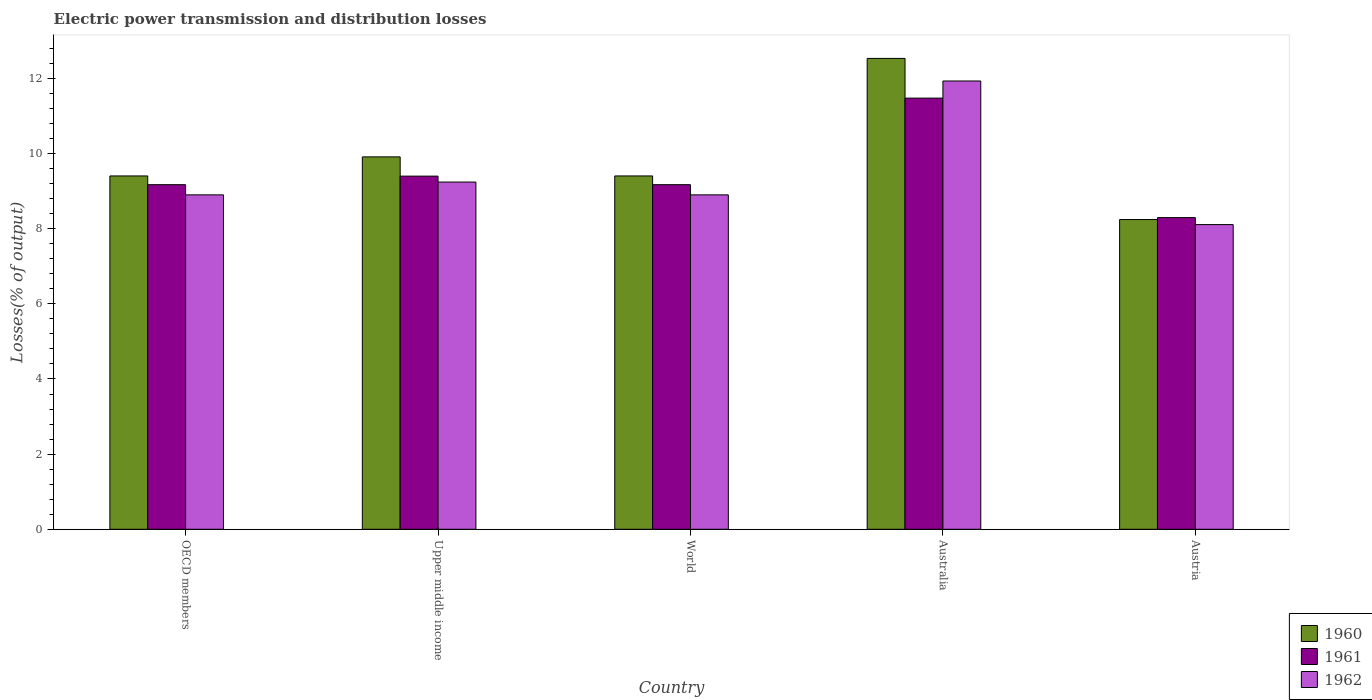How many different coloured bars are there?
Offer a terse response. 3. Are the number of bars per tick equal to the number of legend labels?
Offer a very short reply. Yes. Are the number of bars on each tick of the X-axis equal?
Offer a terse response. Yes. What is the electric power transmission and distribution losses in 1962 in World?
Offer a very short reply. 8.9. Across all countries, what is the maximum electric power transmission and distribution losses in 1962?
Give a very brief answer. 11.93. Across all countries, what is the minimum electric power transmission and distribution losses in 1962?
Provide a succinct answer. 8.11. What is the total electric power transmission and distribution losses in 1961 in the graph?
Provide a succinct answer. 47.51. What is the difference between the electric power transmission and distribution losses in 1962 in OECD members and that in Upper middle income?
Offer a very short reply. -0.34. What is the difference between the electric power transmission and distribution losses in 1962 in Upper middle income and the electric power transmission and distribution losses in 1961 in OECD members?
Give a very brief answer. 0.07. What is the average electric power transmission and distribution losses in 1961 per country?
Ensure brevity in your answer.  9.5. What is the difference between the electric power transmission and distribution losses of/in 1961 and electric power transmission and distribution losses of/in 1960 in OECD members?
Provide a short and direct response. -0.23. In how many countries, is the electric power transmission and distribution losses in 1962 greater than 4.4 %?
Offer a very short reply. 5. What is the ratio of the electric power transmission and distribution losses in 1961 in Austria to that in OECD members?
Keep it short and to the point. 0.9. Is the difference between the electric power transmission and distribution losses in 1961 in Austria and OECD members greater than the difference between the electric power transmission and distribution losses in 1960 in Austria and OECD members?
Provide a short and direct response. Yes. What is the difference between the highest and the second highest electric power transmission and distribution losses in 1962?
Offer a terse response. -0.34. What is the difference between the highest and the lowest electric power transmission and distribution losses in 1961?
Your response must be concise. 3.18. In how many countries, is the electric power transmission and distribution losses in 1962 greater than the average electric power transmission and distribution losses in 1962 taken over all countries?
Offer a terse response. 1. How many countries are there in the graph?
Provide a succinct answer. 5. What is the difference between two consecutive major ticks on the Y-axis?
Offer a terse response. 2. Are the values on the major ticks of Y-axis written in scientific E-notation?
Give a very brief answer. No. Does the graph contain any zero values?
Offer a very short reply. No. How many legend labels are there?
Your response must be concise. 3. What is the title of the graph?
Your answer should be compact. Electric power transmission and distribution losses. Does "1992" appear as one of the legend labels in the graph?
Provide a short and direct response. No. What is the label or title of the X-axis?
Make the answer very short. Country. What is the label or title of the Y-axis?
Provide a short and direct response. Losses(% of output). What is the Losses(% of output) of 1960 in OECD members?
Ensure brevity in your answer.  9.4. What is the Losses(% of output) of 1961 in OECD members?
Your answer should be compact. 9.17. What is the Losses(% of output) of 1962 in OECD members?
Keep it short and to the point. 8.9. What is the Losses(% of output) of 1960 in Upper middle income?
Keep it short and to the point. 9.91. What is the Losses(% of output) in 1961 in Upper middle income?
Your answer should be compact. 9.4. What is the Losses(% of output) of 1962 in Upper middle income?
Your answer should be very brief. 9.24. What is the Losses(% of output) of 1960 in World?
Offer a terse response. 9.4. What is the Losses(% of output) in 1961 in World?
Give a very brief answer. 9.17. What is the Losses(% of output) in 1962 in World?
Your response must be concise. 8.9. What is the Losses(% of output) of 1960 in Australia?
Ensure brevity in your answer.  12.53. What is the Losses(% of output) of 1961 in Australia?
Ensure brevity in your answer.  11.48. What is the Losses(% of output) in 1962 in Australia?
Ensure brevity in your answer.  11.93. What is the Losses(% of output) of 1960 in Austria?
Offer a very short reply. 8.24. What is the Losses(% of output) in 1961 in Austria?
Your answer should be very brief. 8.3. What is the Losses(% of output) of 1962 in Austria?
Ensure brevity in your answer.  8.11. Across all countries, what is the maximum Losses(% of output) in 1960?
Provide a succinct answer. 12.53. Across all countries, what is the maximum Losses(% of output) of 1961?
Provide a short and direct response. 11.48. Across all countries, what is the maximum Losses(% of output) in 1962?
Provide a short and direct response. 11.93. Across all countries, what is the minimum Losses(% of output) in 1960?
Your answer should be very brief. 8.24. Across all countries, what is the minimum Losses(% of output) in 1961?
Offer a terse response. 8.3. Across all countries, what is the minimum Losses(% of output) of 1962?
Provide a short and direct response. 8.11. What is the total Losses(% of output) in 1960 in the graph?
Your response must be concise. 49.5. What is the total Losses(% of output) in 1961 in the graph?
Give a very brief answer. 47.51. What is the total Losses(% of output) of 1962 in the graph?
Provide a short and direct response. 47.08. What is the difference between the Losses(% of output) of 1960 in OECD members and that in Upper middle income?
Your answer should be compact. -0.51. What is the difference between the Losses(% of output) of 1961 in OECD members and that in Upper middle income?
Offer a very short reply. -0.23. What is the difference between the Losses(% of output) of 1962 in OECD members and that in Upper middle income?
Your answer should be compact. -0.34. What is the difference between the Losses(% of output) in 1960 in OECD members and that in World?
Keep it short and to the point. 0. What is the difference between the Losses(% of output) of 1961 in OECD members and that in World?
Keep it short and to the point. 0. What is the difference between the Losses(% of output) of 1962 in OECD members and that in World?
Offer a very short reply. 0. What is the difference between the Losses(% of output) in 1960 in OECD members and that in Australia?
Provide a short and direct response. -3.13. What is the difference between the Losses(% of output) of 1961 in OECD members and that in Australia?
Keep it short and to the point. -2.3. What is the difference between the Losses(% of output) of 1962 in OECD members and that in Australia?
Your response must be concise. -3.03. What is the difference between the Losses(% of output) in 1960 in OECD members and that in Austria?
Your response must be concise. 1.16. What is the difference between the Losses(% of output) in 1961 in OECD members and that in Austria?
Your answer should be very brief. 0.88. What is the difference between the Losses(% of output) in 1962 in OECD members and that in Austria?
Make the answer very short. 0.79. What is the difference between the Losses(% of output) in 1960 in Upper middle income and that in World?
Provide a succinct answer. 0.51. What is the difference between the Losses(% of output) of 1961 in Upper middle income and that in World?
Keep it short and to the point. 0.23. What is the difference between the Losses(% of output) in 1962 in Upper middle income and that in World?
Ensure brevity in your answer.  0.34. What is the difference between the Losses(% of output) in 1960 in Upper middle income and that in Australia?
Ensure brevity in your answer.  -2.62. What is the difference between the Losses(% of output) of 1961 in Upper middle income and that in Australia?
Your answer should be very brief. -2.08. What is the difference between the Losses(% of output) of 1962 in Upper middle income and that in Australia?
Provide a succinct answer. -2.69. What is the difference between the Losses(% of output) in 1960 in Upper middle income and that in Austria?
Provide a succinct answer. 1.67. What is the difference between the Losses(% of output) of 1961 in Upper middle income and that in Austria?
Your response must be concise. 1.1. What is the difference between the Losses(% of output) in 1962 in Upper middle income and that in Austria?
Keep it short and to the point. 1.13. What is the difference between the Losses(% of output) in 1960 in World and that in Australia?
Your answer should be compact. -3.13. What is the difference between the Losses(% of output) in 1961 in World and that in Australia?
Give a very brief answer. -2.3. What is the difference between the Losses(% of output) in 1962 in World and that in Australia?
Give a very brief answer. -3.03. What is the difference between the Losses(% of output) of 1960 in World and that in Austria?
Your response must be concise. 1.16. What is the difference between the Losses(% of output) in 1961 in World and that in Austria?
Make the answer very short. 0.88. What is the difference between the Losses(% of output) in 1962 in World and that in Austria?
Keep it short and to the point. 0.79. What is the difference between the Losses(% of output) in 1960 in Australia and that in Austria?
Keep it short and to the point. 4.29. What is the difference between the Losses(% of output) of 1961 in Australia and that in Austria?
Make the answer very short. 3.18. What is the difference between the Losses(% of output) in 1962 in Australia and that in Austria?
Offer a very short reply. 3.82. What is the difference between the Losses(% of output) of 1960 in OECD members and the Losses(% of output) of 1961 in Upper middle income?
Your answer should be very brief. 0.01. What is the difference between the Losses(% of output) in 1960 in OECD members and the Losses(% of output) in 1962 in Upper middle income?
Provide a short and direct response. 0.16. What is the difference between the Losses(% of output) in 1961 in OECD members and the Losses(% of output) in 1962 in Upper middle income?
Ensure brevity in your answer.  -0.07. What is the difference between the Losses(% of output) of 1960 in OECD members and the Losses(% of output) of 1961 in World?
Your answer should be compact. 0.23. What is the difference between the Losses(% of output) in 1960 in OECD members and the Losses(% of output) in 1962 in World?
Provide a succinct answer. 0.5. What is the difference between the Losses(% of output) in 1961 in OECD members and the Losses(% of output) in 1962 in World?
Provide a succinct answer. 0.27. What is the difference between the Losses(% of output) of 1960 in OECD members and the Losses(% of output) of 1961 in Australia?
Give a very brief answer. -2.07. What is the difference between the Losses(% of output) in 1960 in OECD members and the Losses(% of output) in 1962 in Australia?
Offer a terse response. -2.53. What is the difference between the Losses(% of output) in 1961 in OECD members and the Losses(% of output) in 1962 in Australia?
Make the answer very short. -2.76. What is the difference between the Losses(% of output) in 1960 in OECD members and the Losses(% of output) in 1961 in Austria?
Your response must be concise. 1.11. What is the difference between the Losses(% of output) of 1960 in OECD members and the Losses(% of output) of 1962 in Austria?
Provide a short and direct response. 1.29. What is the difference between the Losses(% of output) in 1961 in OECD members and the Losses(% of output) in 1962 in Austria?
Give a very brief answer. 1.06. What is the difference between the Losses(% of output) in 1960 in Upper middle income and the Losses(% of output) in 1961 in World?
Ensure brevity in your answer.  0.74. What is the difference between the Losses(% of output) of 1960 in Upper middle income and the Losses(% of output) of 1962 in World?
Provide a short and direct response. 1.01. What is the difference between the Losses(% of output) in 1961 in Upper middle income and the Losses(% of output) in 1962 in World?
Make the answer very short. 0.5. What is the difference between the Losses(% of output) of 1960 in Upper middle income and the Losses(% of output) of 1961 in Australia?
Keep it short and to the point. -1.56. What is the difference between the Losses(% of output) of 1960 in Upper middle income and the Losses(% of output) of 1962 in Australia?
Your answer should be very brief. -2.02. What is the difference between the Losses(% of output) in 1961 in Upper middle income and the Losses(% of output) in 1962 in Australia?
Your response must be concise. -2.53. What is the difference between the Losses(% of output) of 1960 in Upper middle income and the Losses(% of output) of 1961 in Austria?
Make the answer very short. 1.62. What is the difference between the Losses(% of output) of 1960 in Upper middle income and the Losses(% of output) of 1962 in Austria?
Your answer should be compact. 1.8. What is the difference between the Losses(% of output) of 1961 in Upper middle income and the Losses(% of output) of 1962 in Austria?
Make the answer very short. 1.29. What is the difference between the Losses(% of output) of 1960 in World and the Losses(% of output) of 1961 in Australia?
Your response must be concise. -2.07. What is the difference between the Losses(% of output) of 1960 in World and the Losses(% of output) of 1962 in Australia?
Ensure brevity in your answer.  -2.53. What is the difference between the Losses(% of output) in 1961 in World and the Losses(% of output) in 1962 in Australia?
Provide a succinct answer. -2.76. What is the difference between the Losses(% of output) of 1960 in World and the Losses(% of output) of 1961 in Austria?
Offer a terse response. 1.11. What is the difference between the Losses(% of output) in 1960 in World and the Losses(% of output) in 1962 in Austria?
Your answer should be compact. 1.29. What is the difference between the Losses(% of output) in 1961 in World and the Losses(% of output) in 1962 in Austria?
Provide a succinct answer. 1.06. What is the difference between the Losses(% of output) of 1960 in Australia and the Losses(% of output) of 1961 in Austria?
Give a very brief answer. 4.24. What is the difference between the Losses(% of output) of 1960 in Australia and the Losses(% of output) of 1962 in Austria?
Your answer should be very brief. 4.42. What is the difference between the Losses(% of output) of 1961 in Australia and the Losses(% of output) of 1962 in Austria?
Give a very brief answer. 3.37. What is the average Losses(% of output) of 1960 per country?
Your response must be concise. 9.9. What is the average Losses(% of output) in 1961 per country?
Offer a very short reply. 9.5. What is the average Losses(% of output) in 1962 per country?
Offer a very short reply. 9.42. What is the difference between the Losses(% of output) of 1960 and Losses(% of output) of 1961 in OECD members?
Your answer should be compact. 0.23. What is the difference between the Losses(% of output) in 1960 and Losses(% of output) in 1962 in OECD members?
Your response must be concise. 0.5. What is the difference between the Losses(% of output) in 1961 and Losses(% of output) in 1962 in OECD members?
Your answer should be very brief. 0.27. What is the difference between the Losses(% of output) in 1960 and Losses(% of output) in 1961 in Upper middle income?
Your answer should be very brief. 0.51. What is the difference between the Losses(% of output) of 1960 and Losses(% of output) of 1962 in Upper middle income?
Your answer should be very brief. 0.67. What is the difference between the Losses(% of output) in 1961 and Losses(% of output) in 1962 in Upper middle income?
Offer a terse response. 0.16. What is the difference between the Losses(% of output) in 1960 and Losses(% of output) in 1961 in World?
Your answer should be compact. 0.23. What is the difference between the Losses(% of output) in 1960 and Losses(% of output) in 1962 in World?
Ensure brevity in your answer.  0.5. What is the difference between the Losses(% of output) of 1961 and Losses(% of output) of 1962 in World?
Offer a very short reply. 0.27. What is the difference between the Losses(% of output) of 1960 and Losses(% of output) of 1961 in Australia?
Provide a short and direct response. 1.06. What is the difference between the Losses(% of output) in 1960 and Losses(% of output) in 1962 in Australia?
Offer a very short reply. 0.6. What is the difference between the Losses(% of output) of 1961 and Losses(% of output) of 1962 in Australia?
Your answer should be compact. -0.46. What is the difference between the Losses(% of output) in 1960 and Losses(% of output) in 1961 in Austria?
Provide a succinct answer. -0.05. What is the difference between the Losses(% of output) in 1960 and Losses(% of output) in 1962 in Austria?
Offer a very short reply. 0.13. What is the difference between the Losses(% of output) of 1961 and Losses(% of output) of 1962 in Austria?
Make the answer very short. 0.19. What is the ratio of the Losses(% of output) in 1960 in OECD members to that in Upper middle income?
Your answer should be compact. 0.95. What is the ratio of the Losses(% of output) in 1961 in OECD members to that in Upper middle income?
Make the answer very short. 0.98. What is the ratio of the Losses(% of output) of 1962 in OECD members to that in Upper middle income?
Your response must be concise. 0.96. What is the ratio of the Losses(% of output) of 1960 in OECD members to that in World?
Ensure brevity in your answer.  1. What is the ratio of the Losses(% of output) in 1961 in OECD members to that in World?
Ensure brevity in your answer.  1. What is the ratio of the Losses(% of output) of 1960 in OECD members to that in Australia?
Ensure brevity in your answer.  0.75. What is the ratio of the Losses(% of output) in 1961 in OECD members to that in Australia?
Your answer should be compact. 0.8. What is the ratio of the Losses(% of output) in 1962 in OECD members to that in Australia?
Your response must be concise. 0.75. What is the ratio of the Losses(% of output) of 1960 in OECD members to that in Austria?
Give a very brief answer. 1.14. What is the ratio of the Losses(% of output) of 1961 in OECD members to that in Austria?
Make the answer very short. 1.11. What is the ratio of the Losses(% of output) in 1962 in OECD members to that in Austria?
Offer a terse response. 1.1. What is the ratio of the Losses(% of output) in 1960 in Upper middle income to that in World?
Offer a terse response. 1.05. What is the ratio of the Losses(% of output) in 1961 in Upper middle income to that in World?
Your answer should be very brief. 1.02. What is the ratio of the Losses(% of output) of 1962 in Upper middle income to that in World?
Keep it short and to the point. 1.04. What is the ratio of the Losses(% of output) of 1960 in Upper middle income to that in Australia?
Give a very brief answer. 0.79. What is the ratio of the Losses(% of output) in 1961 in Upper middle income to that in Australia?
Offer a very short reply. 0.82. What is the ratio of the Losses(% of output) in 1962 in Upper middle income to that in Australia?
Provide a succinct answer. 0.77. What is the ratio of the Losses(% of output) in 1960 in Upper middle income to that in Austria?
Your answer should be compact. 1.2. What is the ratio of the Losses(% of output) in 1961 in Upper middle income to that in Austria?
Offer a very short reply. 1.13. What is the ratio of the Losses(% of output) in 1962 in Upper middle income to that in Austria?
Your answer should be compact. 1.14. What is the ratio of the Losses(% of output) in 1960 in World to that in Australia?
Provide a succinct answer. 0.75. What is the ratio of the Losses(% of output) of 1961 in World to that in Australia?
Your response must be concise. 0.8. What is the ratio of the Losses(% of output) of 1962 in World to that in Australia?
Offer a terse response. 0.75. What is the ratio of the Losses(% of output) in 1960 in World to that in Austria?
Offer a terse response. 1.14. What is the ratio of the Losses(% of output) of 1961 in World to that in Austria?
Your answer should be very brief. 1.11. What is the ratio of the Losses(% of output) in 1962 in World to that in Austria?
Keep it short and to the point. 1.1. What is the ratio of the Losses(% of output) in 1960 in Australia to that in Austria?
Offer a terse response. 1.52. What is the ratio of the Losses(% of output) in 1961 in Australia to that in Austria?
Provide a succinct answer. 1.38. What is the ratio of the Losses(% of output) in 1962 in Australia to that in Austria?
Keep it short and to the point. 1.47. What is the difference between the highest and the second highest Losses(% of output) in 1960?
Provide a succinct answer. 2.62. What is the difference between the highest and the second highest Losses(% of output) in 1961?
Provide a succinct answer. 2.08. What is the difference between the highest and the second highest Losses(% of output) of 1962?
Your answer should be compact. 2.69. What is the difference between the highest and the lowest Losses(% of output) in 1960?
Offer a terse response. 4.29. What is the difference between the highest and the lowest Losses(% of output) of 1961?
Provide a succinct answer. 3.18. What is the difference between the highest and the lowest Losses(% of output) of 1962?
Offer a very short reply. 3.82. 